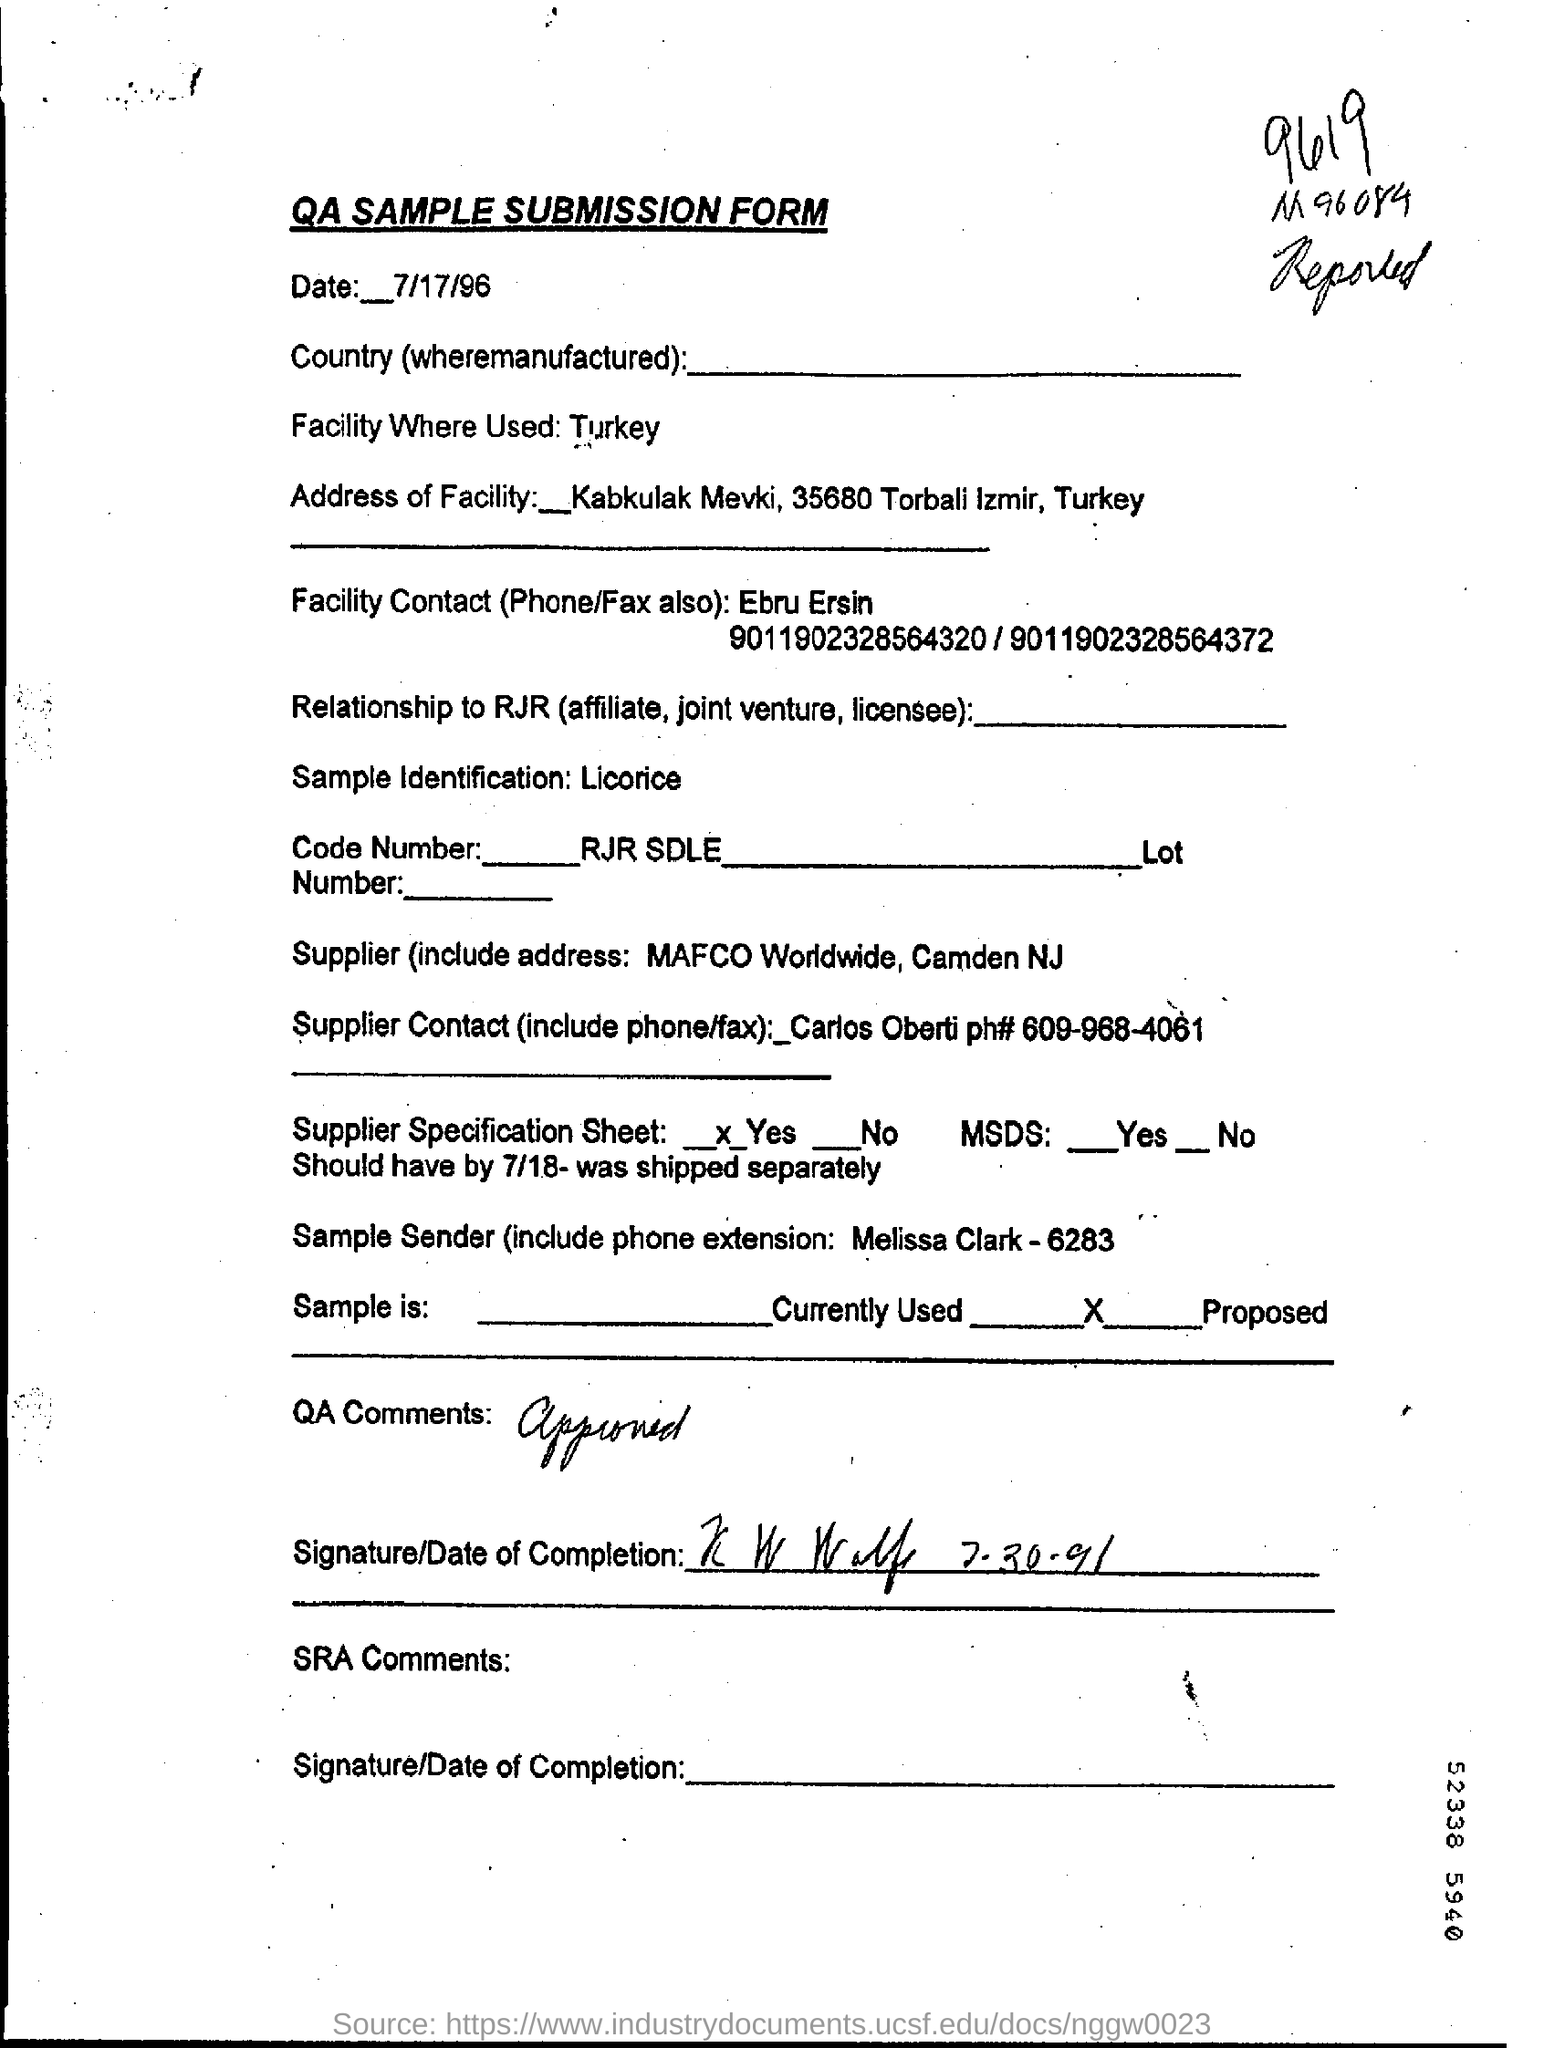What is the date in the sample submission form?
Offer a terse response. 7/17/96. Who is facility contact ?
Keep it short and to the point. Ebru Ersin. Which country's facility where used?
Provide a succinct answer. Turkey. 